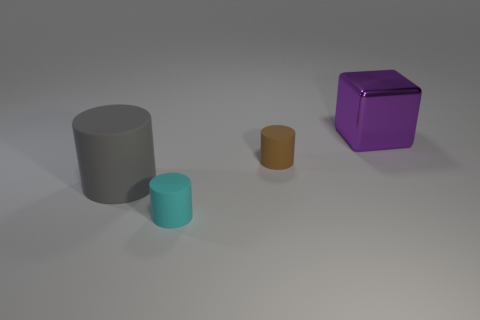How many gray matte objects are the same size as the gray cylinder?
Your answer should be very brief. 0. What size is the rubber object that is to the left of the rubber cylinder in front of the big gray thing?
Give a very brief answer. Large. There is a large object that is in front of the large purple object; does it have the same shape as the small thing that is behind the cyan object?
Keep it short and to the point. Yes. The thing that is both in front of the block and behind the big matte cylinder is what color?
Ensure brevity in your answer.  Brown. What is the color of the cylinder that is to the right of the cyan cylinder?
Provide a short and direct response. Brown. Are there any small rubber things in front of the large thing that is in front of the large purple thing?
Make the answer very short. Yes. Are there any other large purple cubes that have the same material as the large purple cube?
Offer a very short reply. No. How many matte cylinders are there?
Provide a succinct answer. 3. What is the material of the big thing that is left of the big object that is behind the big gray rubber cylinder?
Provide a succinct answer. Rubber. What color is the small thing that is the same material as the cyan cylinder?
Your answer should be compact. Brown. 